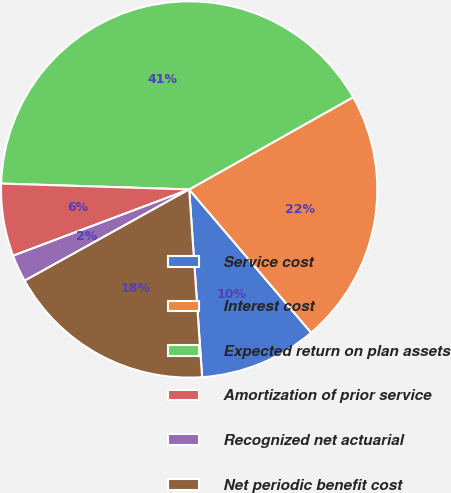Convert chart. <chart><loc_0><loc_0><loc_500><loc_500><pie_chart><fcel>Service cost<fcel>Interest cost<fcel>Expected return on plan assets<fcel>Amortization of prior service<fcel>Recognized net actuarial<fcel>Net periodic benefit cost<nl><fcel>10.13%<fcel>21.93%<fcel>41.34%<fcel>6.23%<fcel>2.33%<fcel>18.03%<nl></chart> 